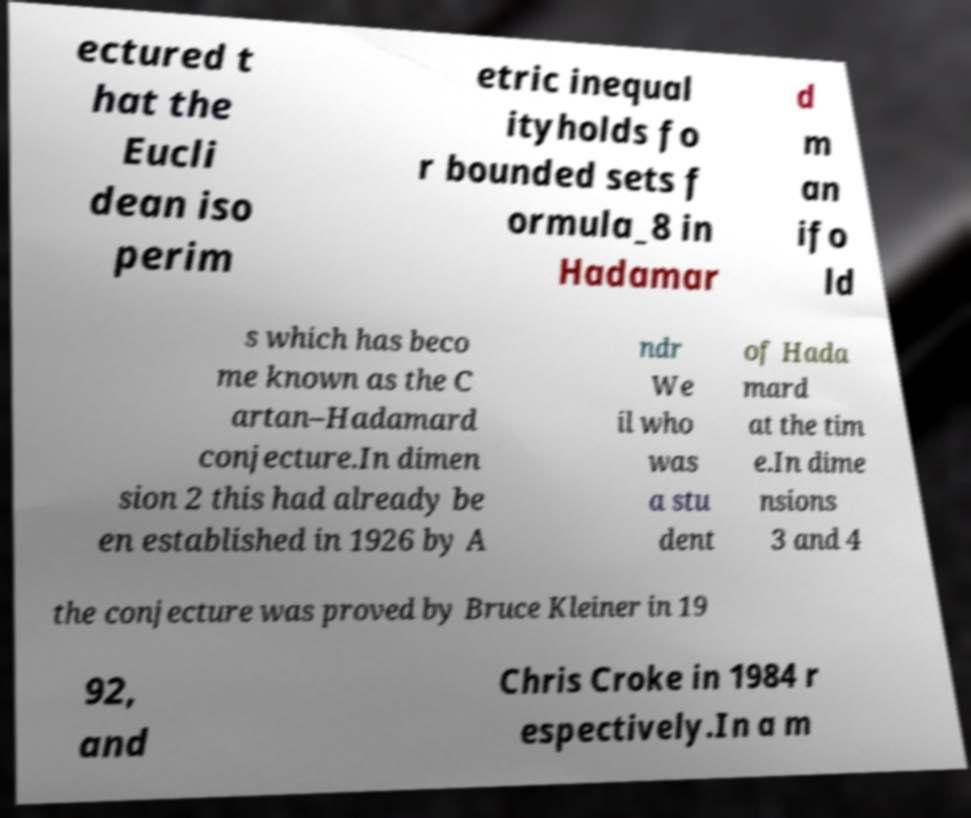What messages or text are displayed in this image? I need them in a readable, typed format. ectured t hat the Eucli dean iso perim etric inequal ityholds fo r bounded sets f ormula_8 in Hadamar d m an ifo ld s which has beco me known as the C artan–Hadamard conjecture.In dimen sion 2 this had already be en established in 1926 by A ndr We il who was a stu dent of Hada mard at the tim e.In dime nsions 3 and 4 the conjecture was proved by Bruce Kleiner in 19 92, and Chris Croke in 1984 r espectively.In a m 